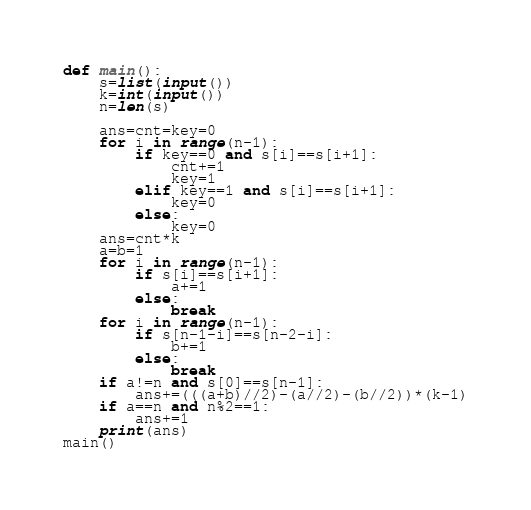Convert code to text. <code><loc_0><loc_0><loc_500><loc_500><_Python_>def main():
    s=list(input())
    k=int(input())
    n=len(s)

    ans=cnt=key=0
    for i in range(n-1):
        if key==0 and s[i]==s[i+1]:
            cnt+=1
            key=1
        elif key==1 and s[i]==s[i+1]:
            key=0
        else:
            key=0
    ans=cnt*k
    a=b=1
    for i in range(n-1):
        if s[i]==s[i+1]:
            a+=1
        else:
            break
    for i in range(n-1):
        if s[n-1-i]==s[n-2-i]:
            b+=1
        else:
            break
    if a!=n and s[0]==s[n-1]:
        ans+=(((a+b)//2)-(a//2)-(b//2))*(k-1)
    if a==n and n%2==1:
        ans+=1
    print(ans)
main()</code> 